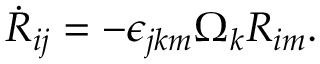Convert formula to latex. <formula><loc_0><loc_0><loc_500><loc_500>\begin{array} { r } { \dot { R } _ { i j } = - \epsilon _ { j k m } \Omega _ { k } R _ { i m } . } \end{array}</formula> 